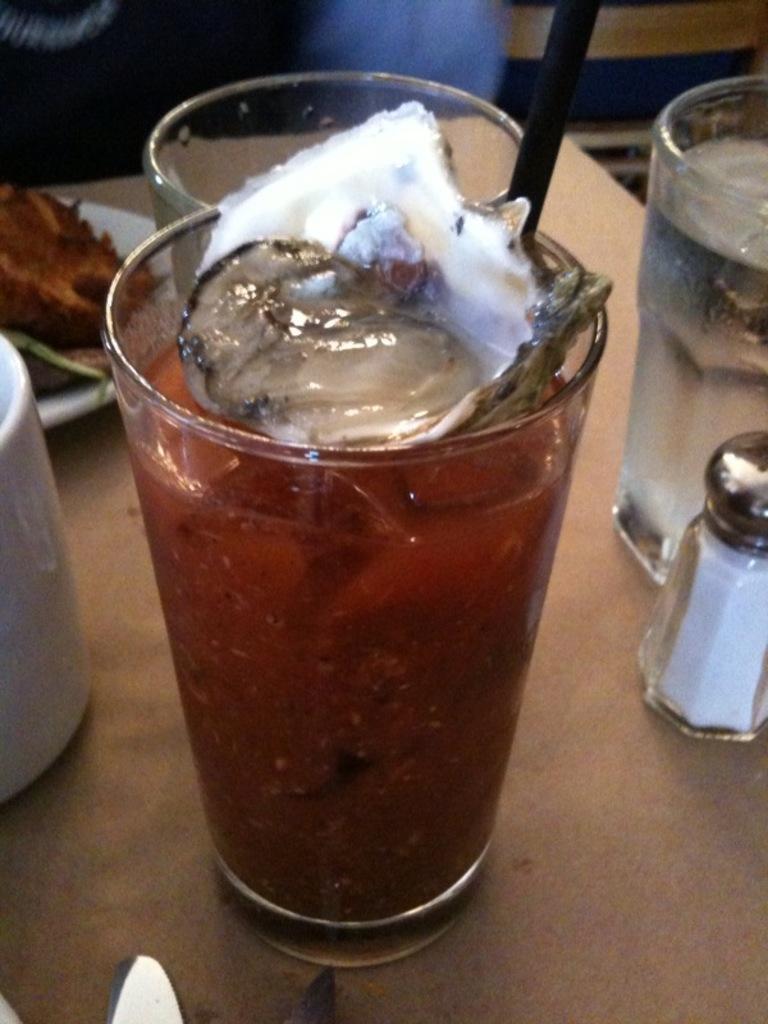Can you describe this image briefly? In this image there is a wooden object towards the bottom of the image that looks like a table, there are glasses, there is the drink in the glass, there is a spoon towards the top of the image, there is a salt shaker towards the right of the image, there is a plate towards the left of the image, there is food on the plate, there is an object towards the left of the image, there are objects towards the bottom of the image, there are objects towards the top of the image. 